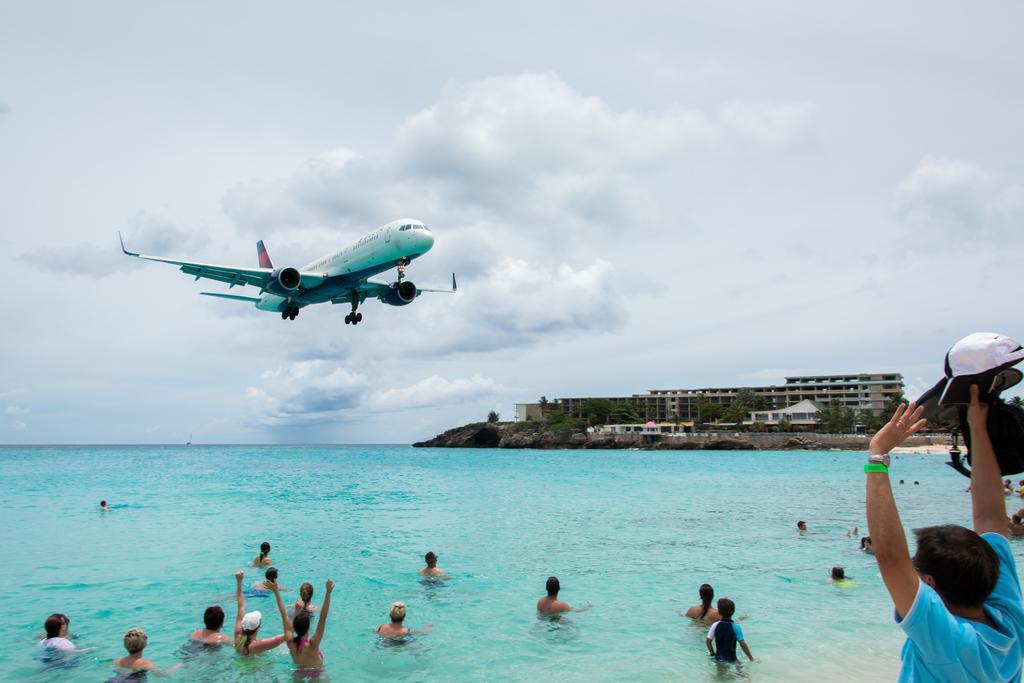Could you give a brief overview of what you see in this image? In this picture we can see so many people are in the water, top we can see plane in the air, side we can see some buildings. 